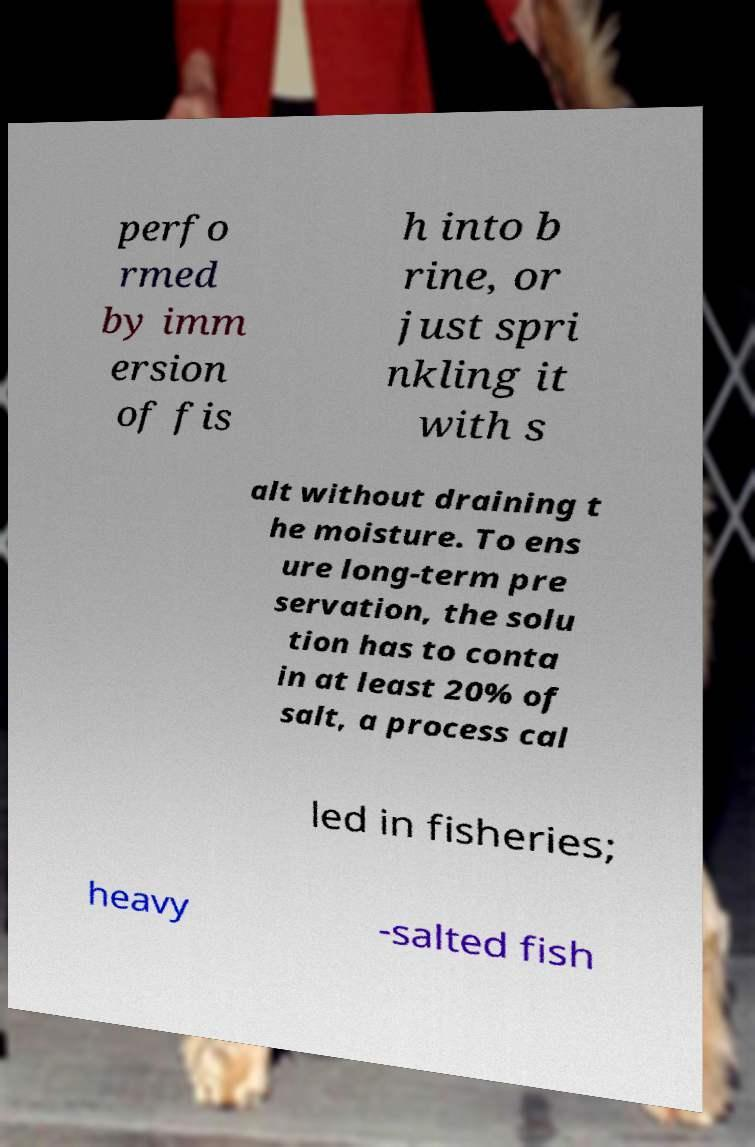What messages or text are displayed in this image? I need them in a readable, typed format. perfo rmed by imm ersion of fis h into b rine, or just spri nkling it with s alt without draining t he moisture. To ens ure long-term pre servation, the solu tion has to conta in at least 20% of salt, a process cal led in fisheries; heavy -salted fish 